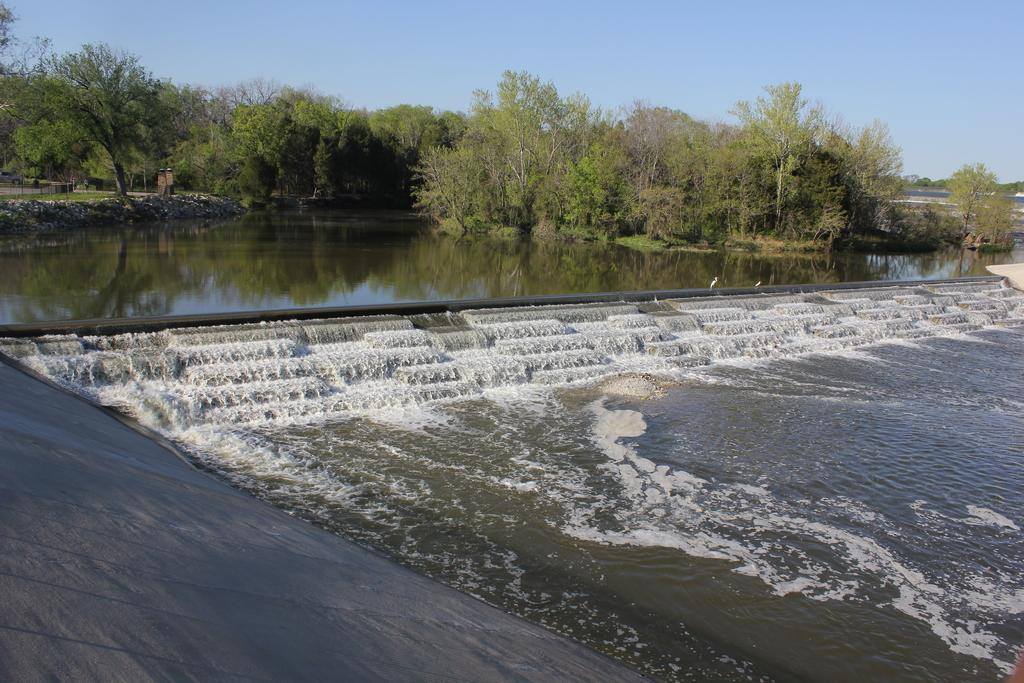What is the main subject in the center of the image? There is water in the center of the image. What type of vegetation can be seen at the top side of the image? There are trees at the top side of the image. Where is the quartz located in the image? There is no quartz present in the image. What type of pipe can be seen in the image? There is no pipe present in the image. 